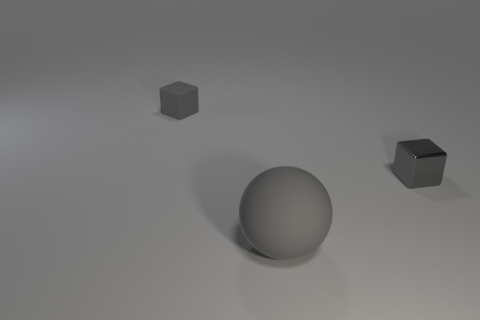Add 3 things. How many objects exist? 6 Subtract all blocks. How many objects are left? 1 Subtract 1 balls. How many balls are left? 0 Subtract all purple cubes. Subtract all cyan cylinders. How many cubes are left? 2 Subtract all big matte spheres. Subtract all large purple things. How many objects are left? 2 Add 2 tiny gray metallic cubes. How many tiny gray metallic cubes are left? 3 Add 2 tiny matte things. How many tiny matte things exist? 3 Subtract 0 blue cubes. How many objects are left? 3 